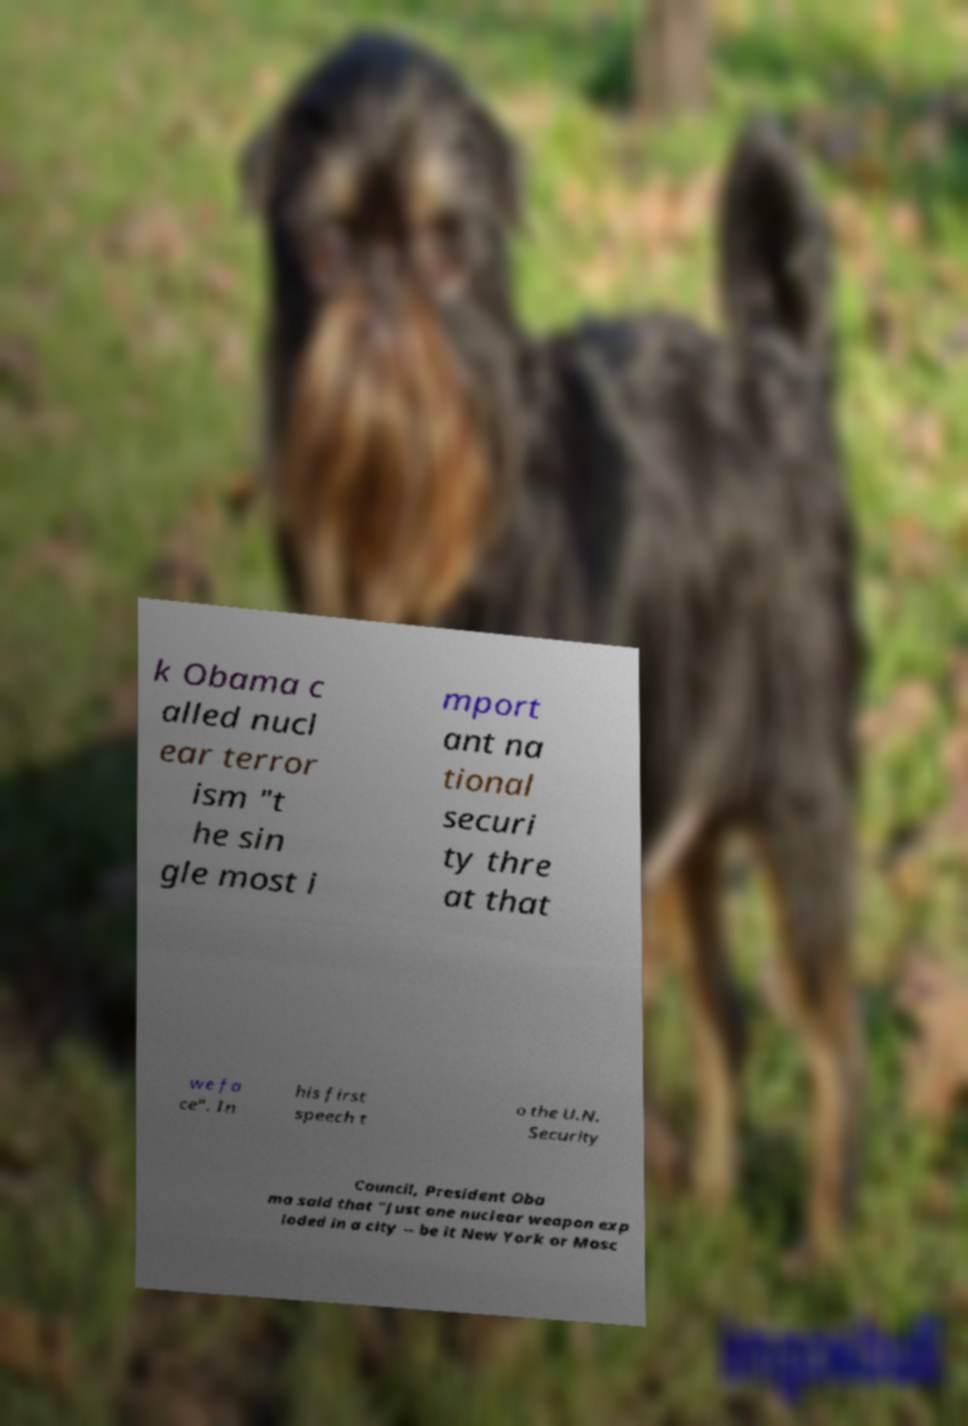Could you assist in decoding the text presented in this image and type it out clearly? k Obama c alled nucl ear terror ism "t he sin gle most i mport ant na tional securi ty thre at that we fa ce". In his first speech t o the U.N. Security Council, President Oba ma said that "Just one nuclear weapon exp loded in a city -- be it New York or Mosc 